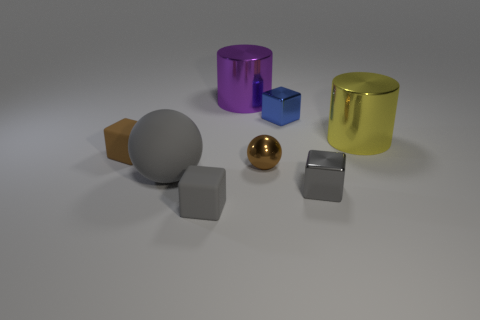There is a big object that is right of the big gray sphere and to the left of the tiny blue shiny thing; what is its shape? The large object located to the right of the big gray sphere and to the left of the small blue glossy cube is a cylinder. It has a tall, circular profile that differentiates it from the other shapes around it. 